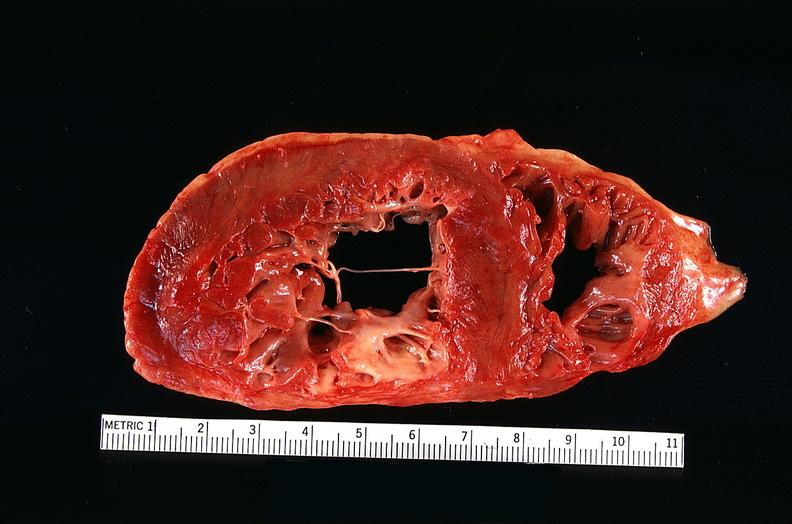s cardiovascular present?
Answer the question using a single word or phrase. Yes 